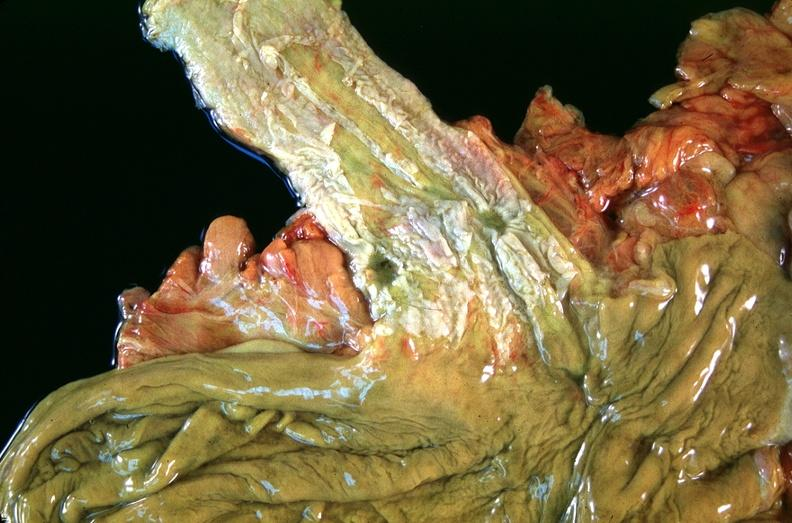does this image show esophogus, varices due to portal hypertension from cirrhosis, hcv?
Answer the question using a single word or phrase. Yes 